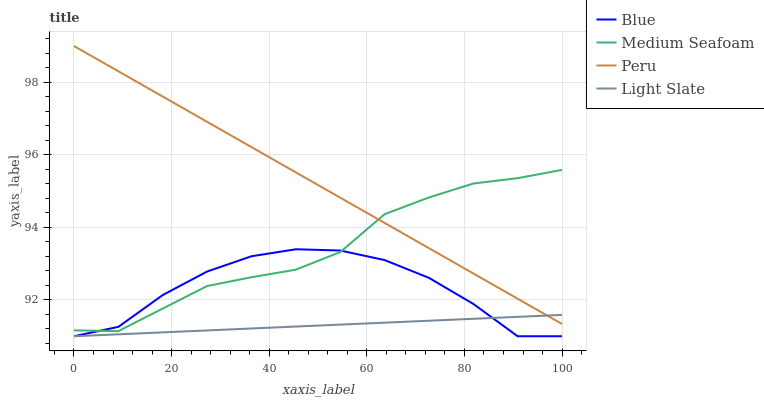Does Light Slate have the minimum area under the curve?
Answer yes or no. Yes. Does Peru have the maximum area under the curve?
Answer yes or no. Yes. Does Medium Seafoam have the minimum area under the curve?
Answer yes or no. No. Does Medium Seafoam have the maximum area under the curve?
Answer yes or no. No. Is Peru the smoothest?
Answer yes or no. Yes. Is Blue the roughest?
Answer yes or no. Yes. Is Light Slate the smoothest?
Answer yes or no. No. Is Light Slate the roughest?
Answer yes or no. No. Does Blue have the lowest value?
Answer yes or no. Yes. Does Medium Seafoam have the lowest value?
Answer yes or no. No. Does Peru have the highest value?
Answer yes or no. Yes. Does Medium Seafoam have the highest value?
Answer yes or no. No. Is Blue less than Peru?
Answer yes or no. Yes. Is Peru greater than Blue?
Answer yes or no. Yes. Does Blue intersect Light Slate?
Answer yes or no. Yes. Is Blue less than Light Slate?
Answer yes or no. No. Is Blue greater than Light Slate?
Answer yes or no. No. Does Blue intersect Peru?
Answer yes or no. No. 